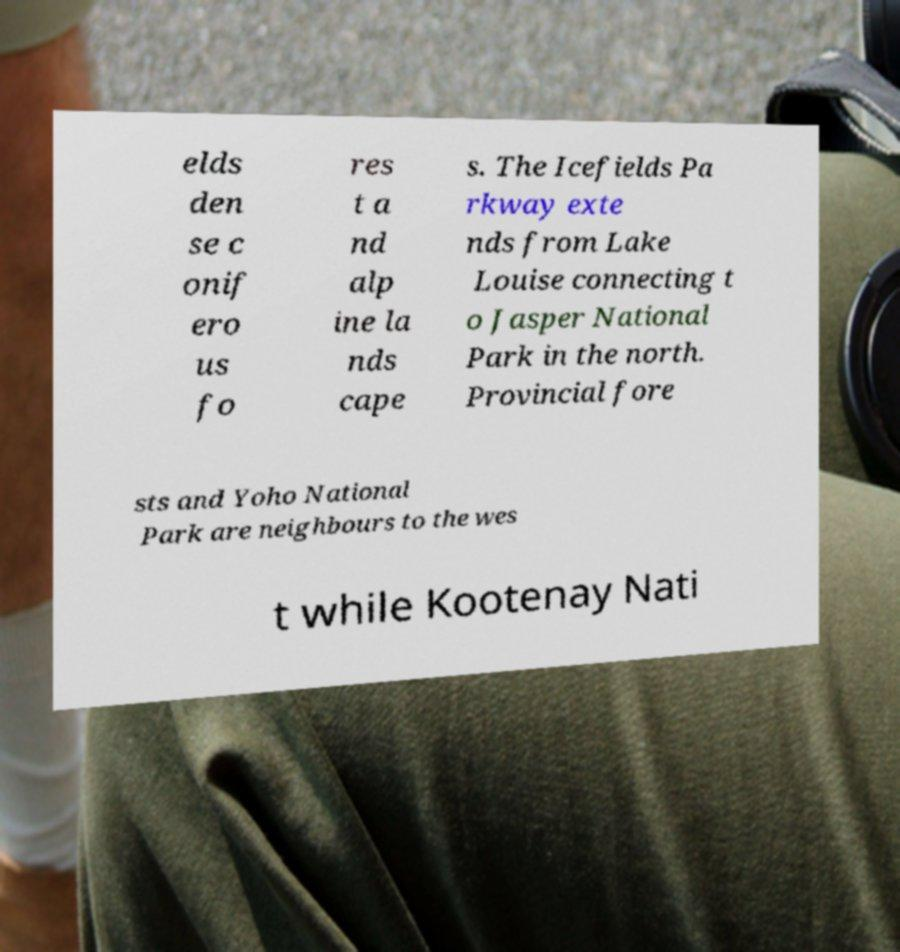Can you accurately transcribe the text from the provided image for me? elds den se c onif ero us fo res t a nd alp ine la nds cape s. The Icefields Pa rkway exte nds from Lake Louise connecting t o Jasper National Park in the north. Provincial fore sts and Yoho National Park are neighbours to the wes t while Kootenay Nati 